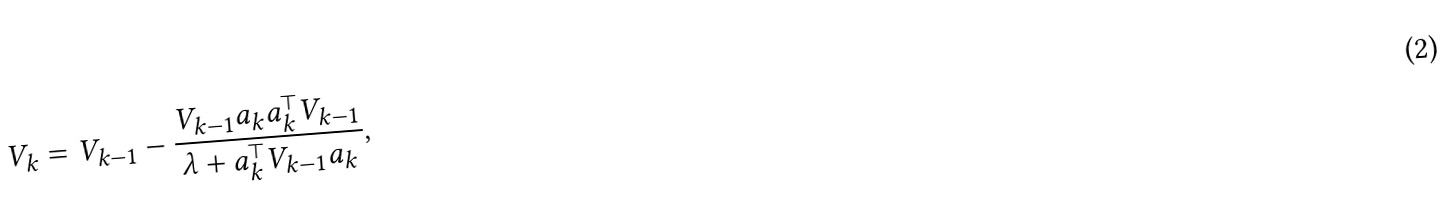Convert formula to latex. <formula><loc_0><loc_0><loc_500><loc_500>V _ { k } = V _ { k - 1 } - \frac { V _ { k - 1 } a _ { k } a _ { k } ^ { \top } V _ { k - 1 } } { \lambda + a _ { k } ^ { \top } V _ { k - 1 } a _ { k } } ,</formula> 